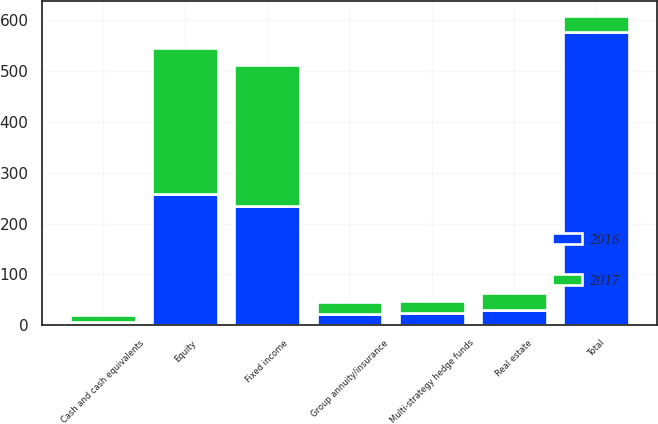<chart> <loc_0><loc_0><loc_500><loc_500><stacked_bar_chart><ecel><fcel>Group annuity/insurance<fcel>Cash and cash equivalents<fcel>Equity<fcel>Fixed income<fcel>Multi-strategy hedge funds<fcel>Real estate<fcel>Total<nl><fcel>2017<fcel>23.3<fcel>12.5<fcel>285.9<fcel>277.7<fcel>24.6<fcel>32.6<fcel>30.7<nl><fcel>2016<fcel>22.8<fcel>6.9<fcel>258.8<fcel>235.4<fcel>23.1<fcel>30.7<fcel>577.7<nl></chart> 